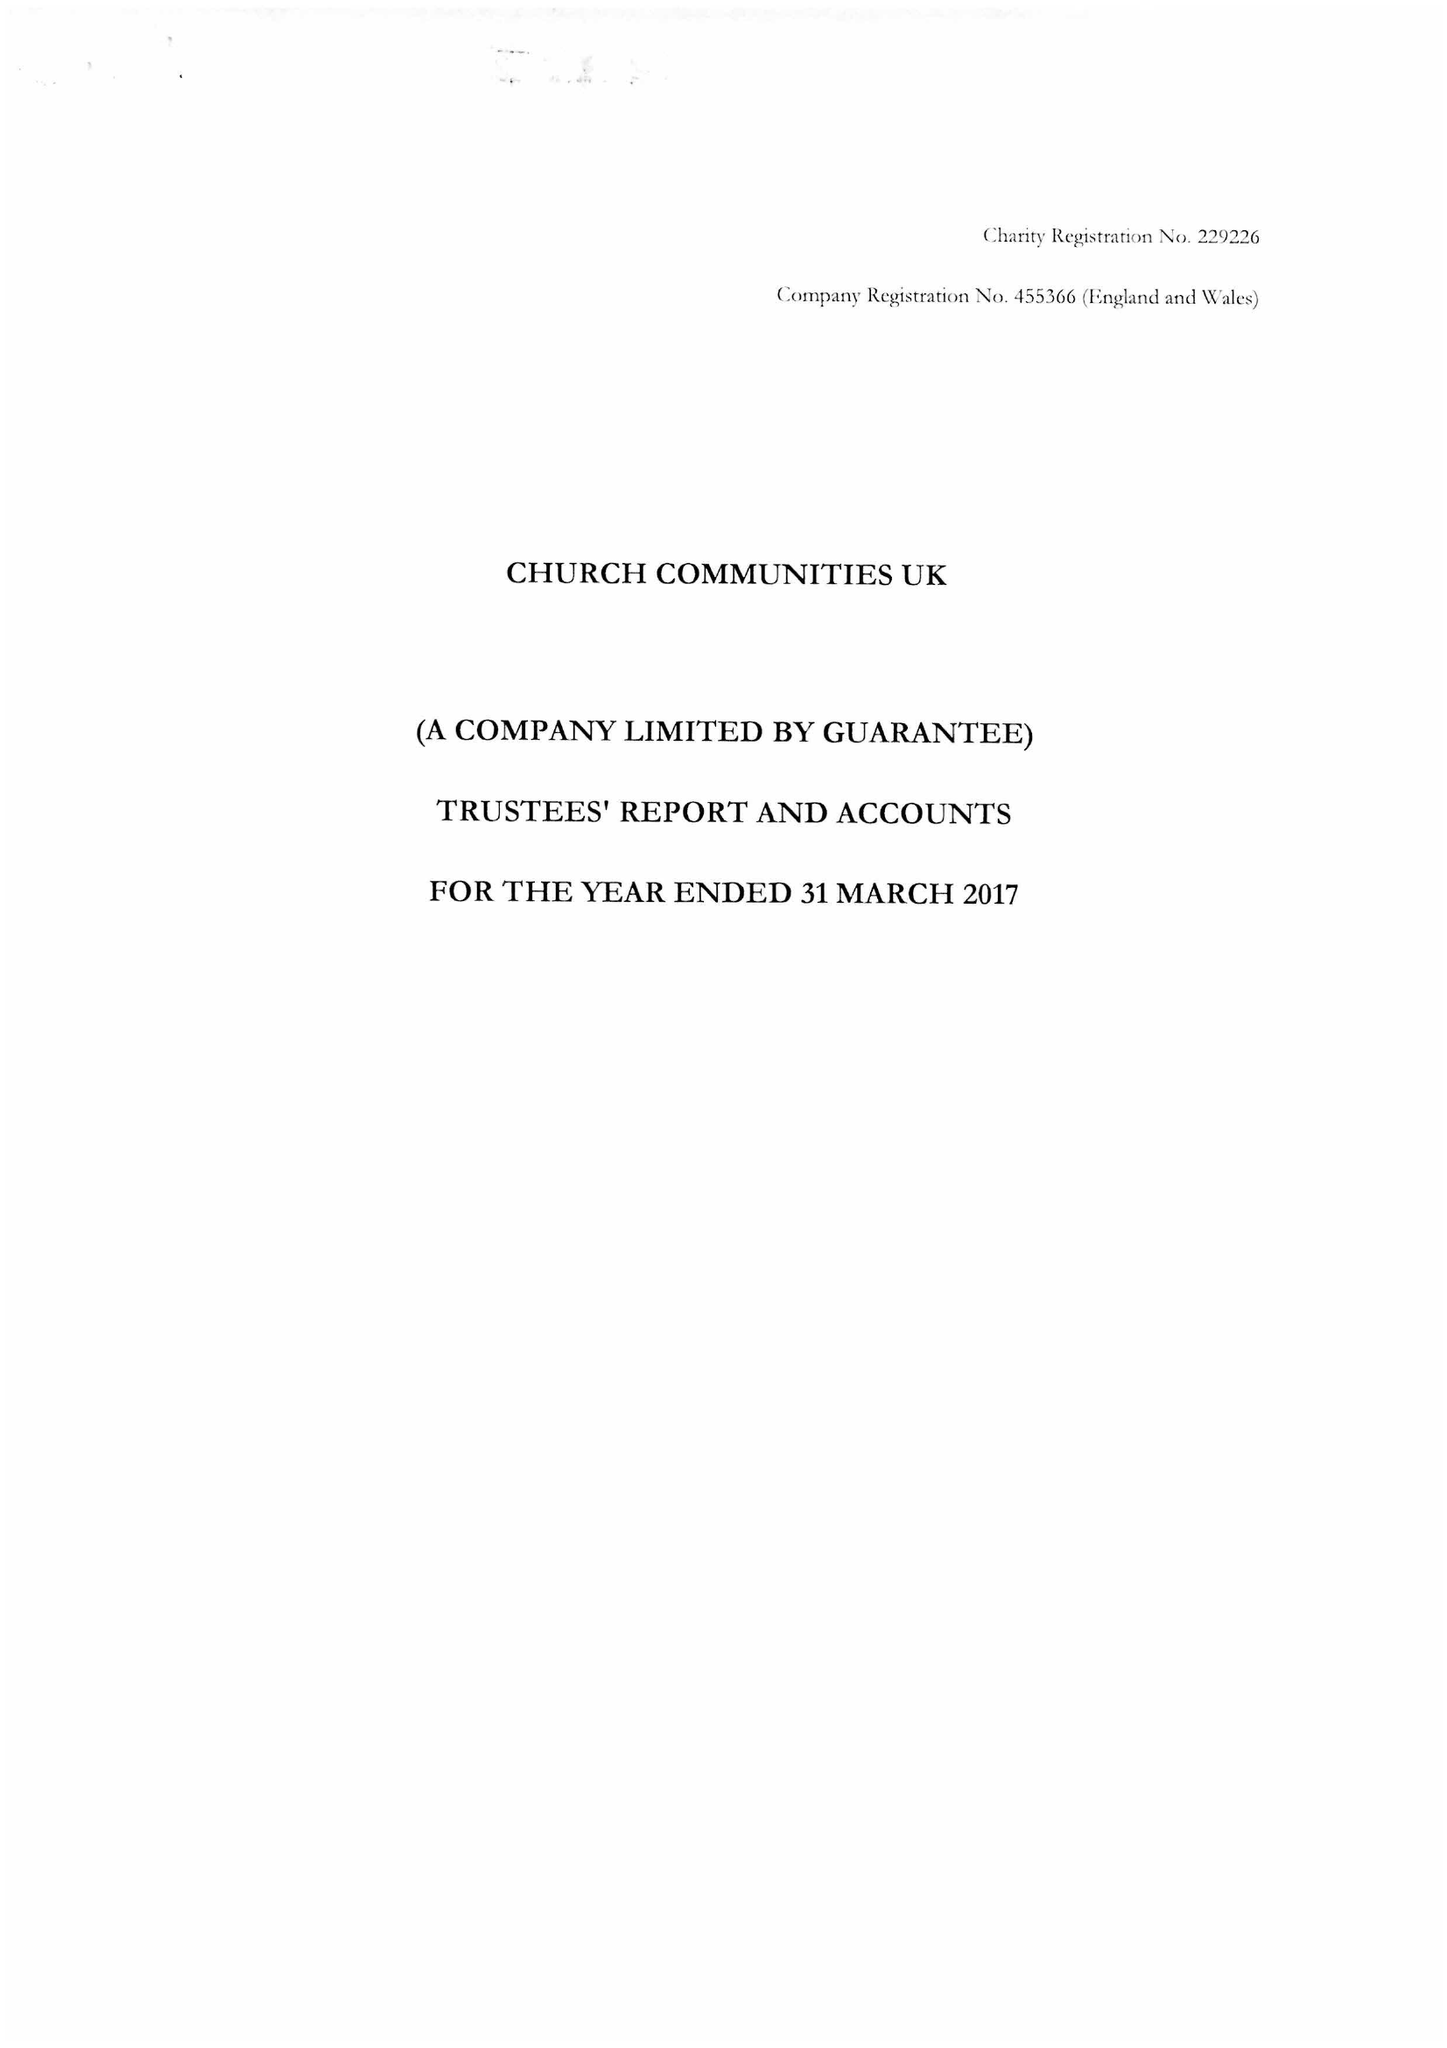What is the value for the address__street_line?
Answer the question using a single word or phrase. BRIGHTLING ROAD 